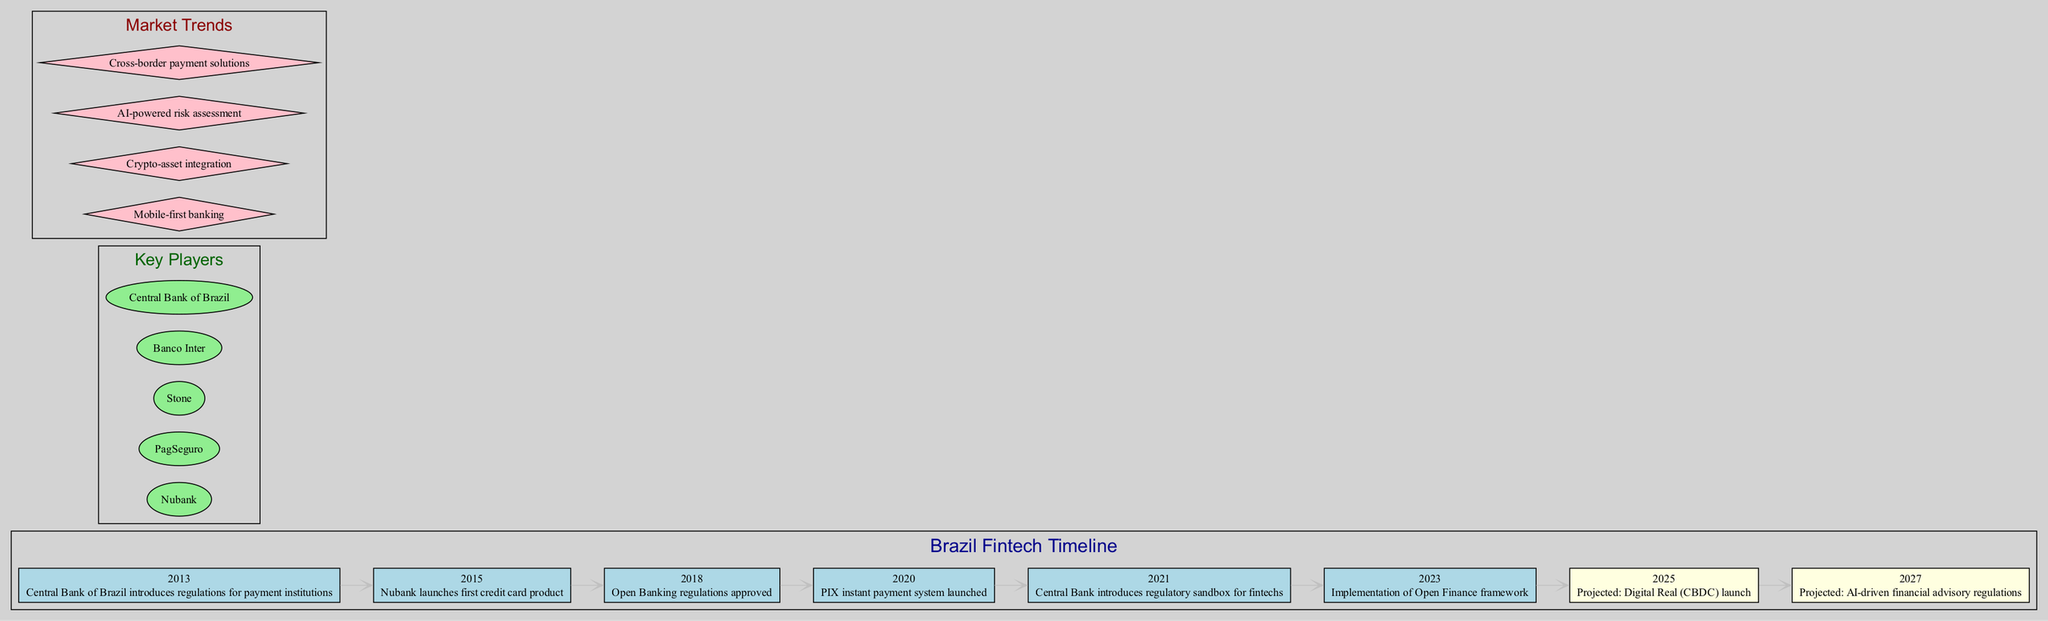What year did the Central Bank of Brazil introduce regulations for payment institutions? The diagram shows that the event "Central Bank of Brazil introduces regulations for payment institutions" occurred in the year 2013.
Answer: 2013 What is the projected year for the launch of the Digital Real (CBDC)? According to the timeline, the projected launch year for the Digital Real (CBDC) is 2025, as indicated in the entry for that year within the diagram.
Answer: 2025 How many key players are listed in the diagram? The diagram outlines six key players in the Brazilian fintech market, which can be counted directly from the "Key Players" section of the diagram.
Answer: 5 What event occurred immediately after the approval of Open Banking regulations? Looking at the timeline, after the approval of Open Banking regulations in 2018, the next event listed is the launch of the PIX instant payment system in 2020.
Answer: PIX instant payment system launched What common theme can be observed among the projected events? The projected events in the timeline focus on advancements in digital finance, specifically "Digital Real launch" and "AI-driven financial advisory regulations," indicating a trend towards digitalization and technology integration in finance.
Answer: Digitalization and technology integration Which color represents the projected events in the timeline? The diagram's nodes for projected events are filled with light yellow color, which differentiates them from non-projected events that are light blue.
Answer: Light yellow What event signifies the beginning of the open banking era in Brazil? In 2018, the approval of Open Banking regulations marked the beginning of the open banking era in Brazil, as highlighted in the timeline.
Answer: Open Banking regulations approved Which market trend relates to the use of artificial intelligence in financial services? The diagram lists "AI-powered risk assessment" as a market trend, indicating its relevance to the use of artificial intelligence in the fintech sector.
Answer: AI-powered risk assessment Which event comes last in the timeline according to the projections? The last event projected in the timeline is "AI-driven financial advisory regulations," which is set for 2027 and is the final item listed in the projected events section.
Answer: AI-driven financial advisory regulations 